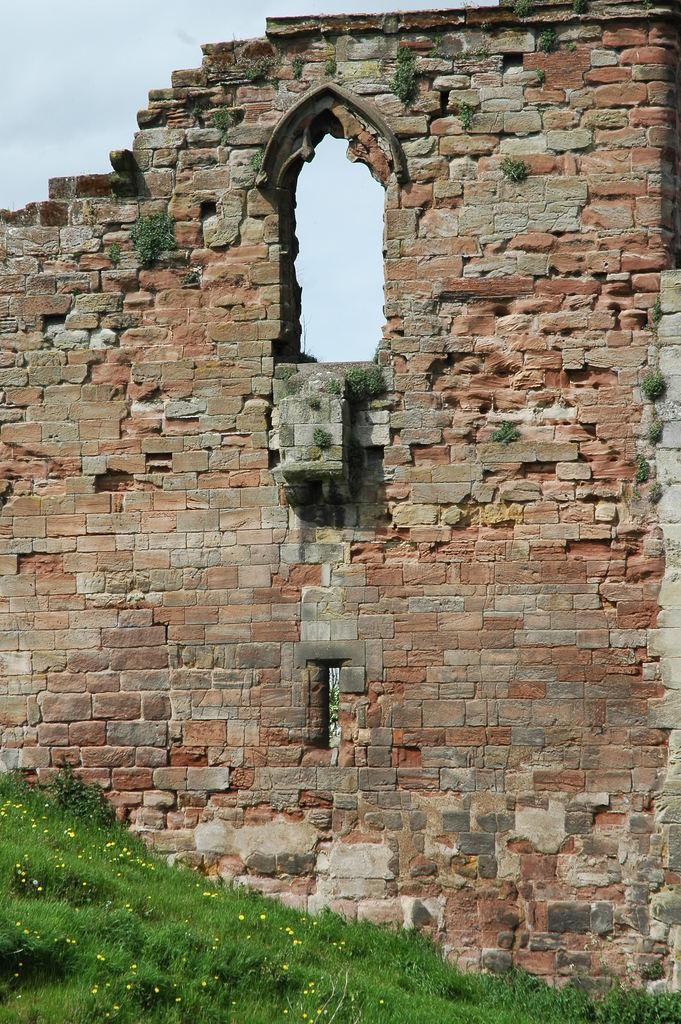What type of vegetation is present in the image? There is grass in the image. What type of structure can be seen in the image? There is a brick wall in the image. What can be seen in the background of the image? The sky is visible in the background of the image. What word is written on the grass in the image? There are no words written on the grass in the image. What time of day is depicted in the image? The time of day is not specified in the image, as there are no clues to indicate whether it is morning, afternoon, or evening. 